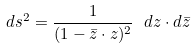<formula> <loc_0><loc_0><loc_500><loc_500>d s ^ { 2 } = \frac { 1 } { ( 1 - \bar { z } \cdot z ) ^ { 2 } } \ d z \cdot d \bar { z }</formula> 